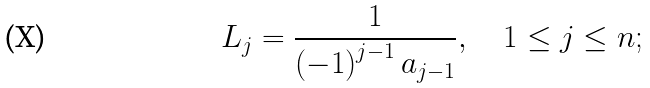Convert formula to latex. <formula><loc_0><loc_0><loc_500><loc_500>L _ { j } = \frac { 1 } { \left ( - 1 \right ) ^ { j - 1 } a _ { j - 1 } } , \quad 1 \leq j \leq n ;</formula> 